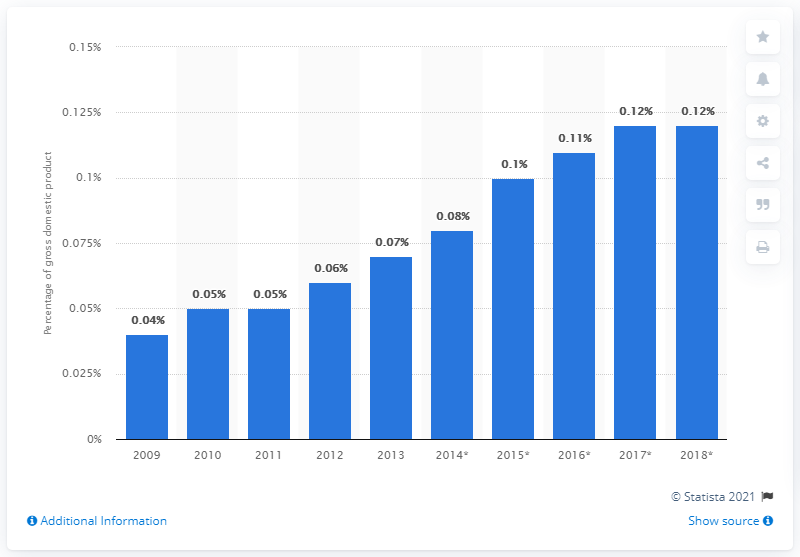Point out several critical features in this image. In 2013, B2C e-commerce accounted for only 0.07% of the GDP of the Middle East and Africa. 